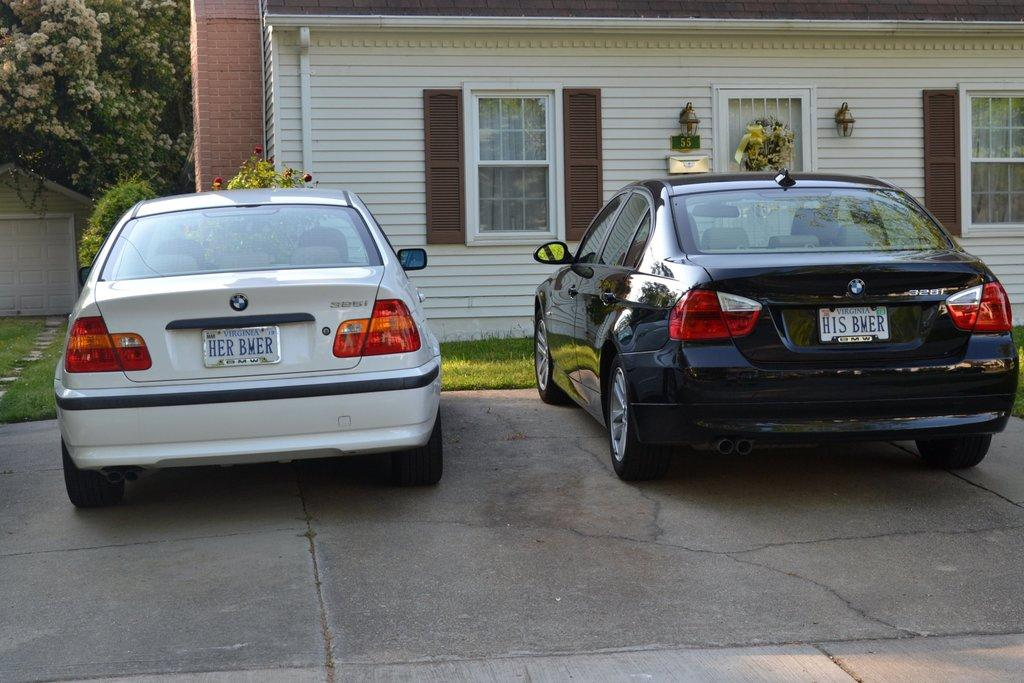<image>
Share a concise interpretation of the image provided. Two cars parked in front of a white house with vanity plates reading "Her BMER" and "His BMER." 